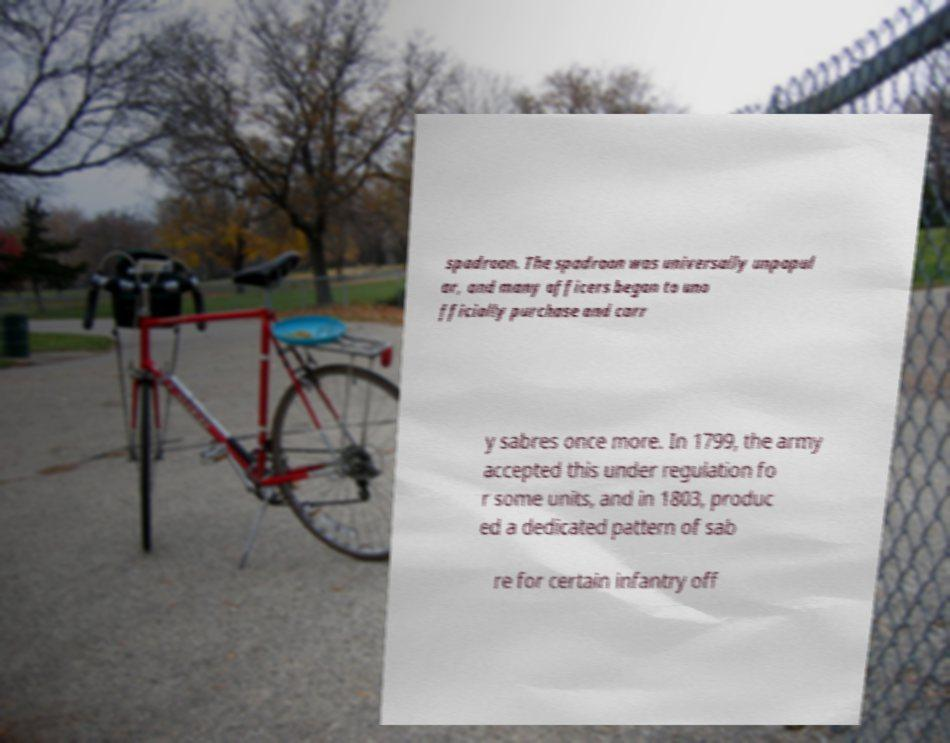Please identify and transcribe the text found in this image. spadroon. The spadroon was universally unpopul ar, and many officers began to uno fficially purchase and carr y sabres once more. In 1799, the army accepted this under regulation fo r some units, and in 1803, produc ed a dedicated pattern of sab re for certain infantry off 